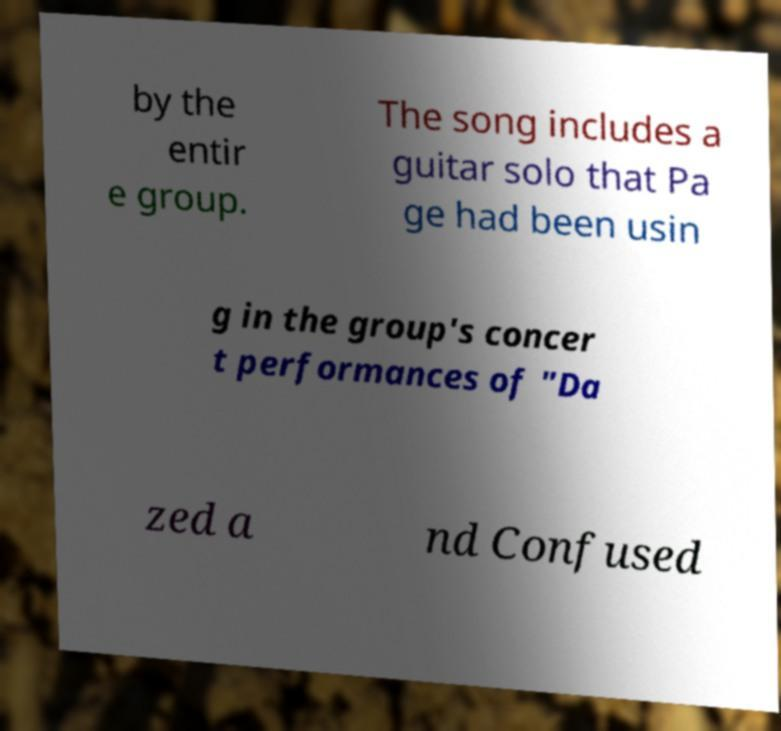Can you read and provide the text displayed in the image?This photo seems to have some interesting text. Can you extract and type it out for me? by the entir e group. The song includes a guitar solo that Pa ge had been usin g in the group's concer t performances of "Da zed a nd Confused 